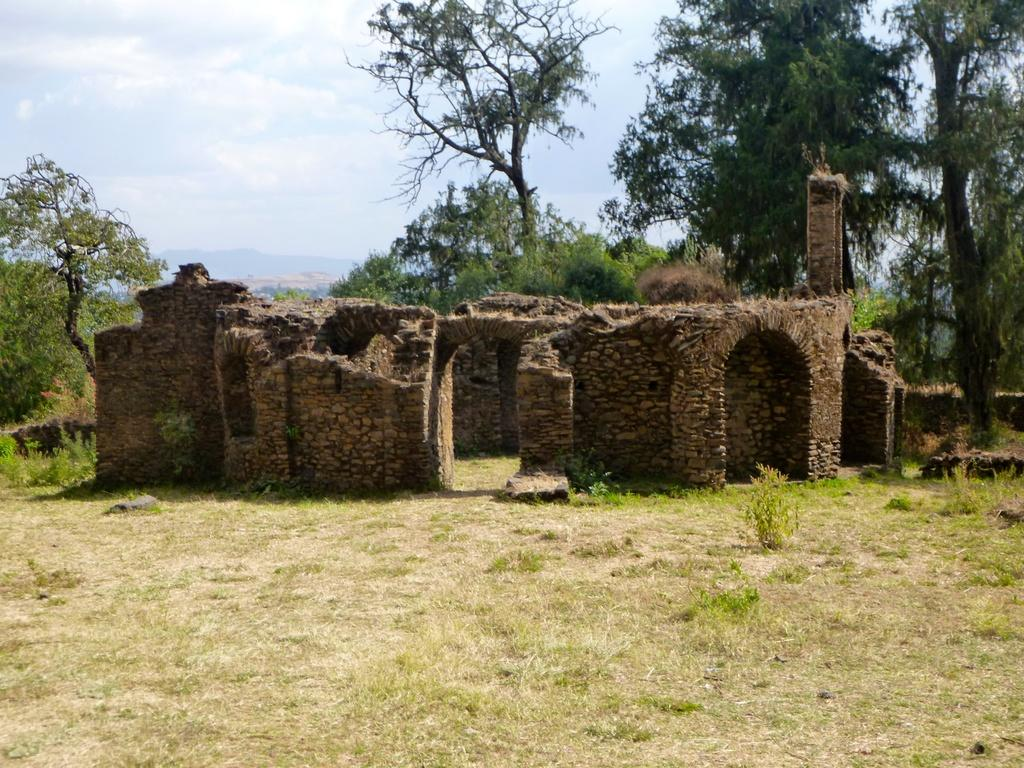What type of structure is in the image? There is an old building in the image. What can be seen in the background of the image? The sky is visible in the image. What type of vegetation is at the top of the image? There is a tree at the top of the image. What type of ground cover is at the bottom of the image? Grass is present at the bottom of the image. Where is the throne located in the image? There is no throne present in the image. What time of day is it in the image? The time of day cannot be determined from the image alone, as there are no specific clues or indicators of time. 